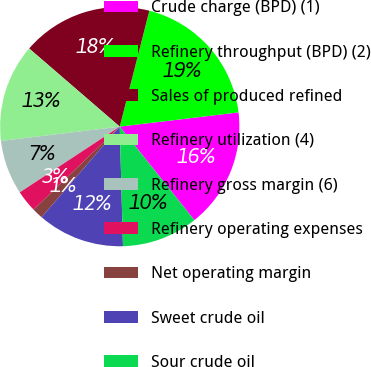<chart> <loc_0><loc_0><loc_500><loc_500><pie_chart><fcel>Crude charge (BPD) (1)<fcel>Refinery throughput (BPD) (2)<fcel>Sales of produced refined<fcel>Refinery utilization (4)<fcel>Refinery gross margin (6)<fcel>Refinery operating expenses<fcel>Net operating margin<fcel>Sweet crude oil<fcel>Sour crude oil<nl><fcel>16.18%<fcel>19.12%<fcel>17.65%<fcel>13.24%<fcel>7.35%<fcel>2.94%<fcel>1.47%<fcel>11.76%<fcel>10.29%<nl></chart> 